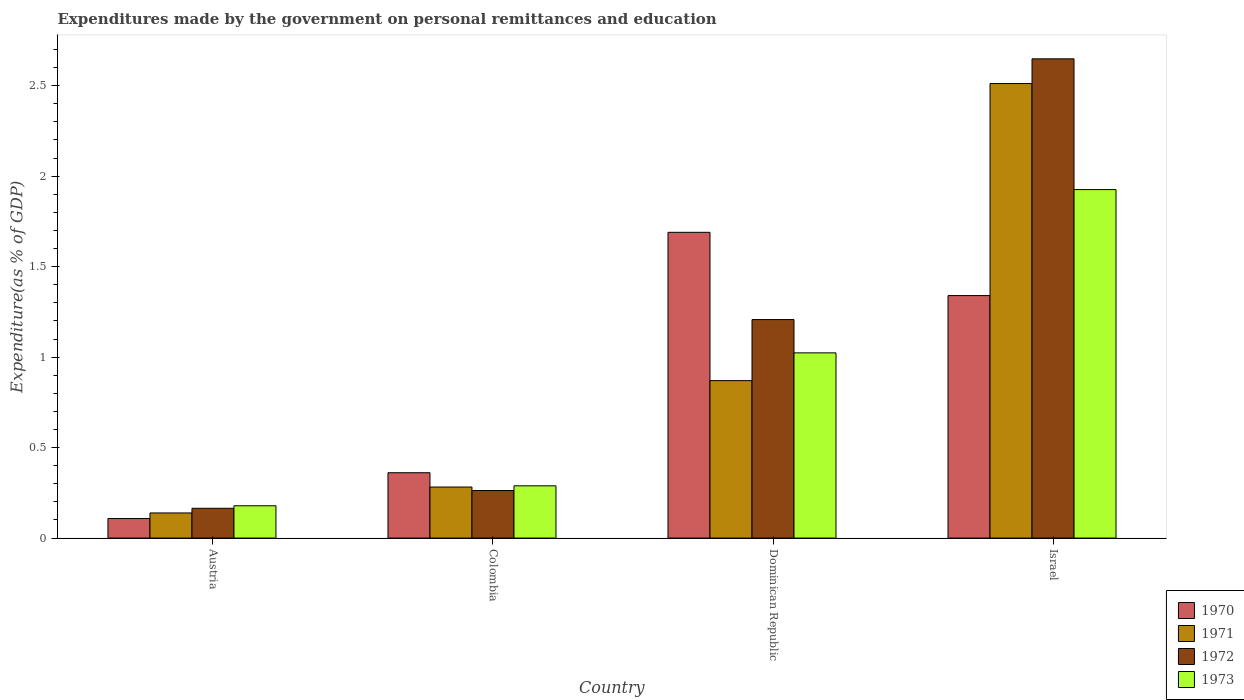How many different coloured bars are there?
Ensure brevity in your answer.  4. How many groups of bars are there?
Your answer should be compact. 4. Are the number of bars per tick equal to the number of legend labels?
Provide a short and direct response. Yes. How many bars are there on the 4th tick from the right?
Keep it short and to the point. 4. In how many cases, is the number of bars for a given country not equal to the number of legend labels?
Keep it short and to the point. 0. What is the expenditures made by the government on personal remittances and education in 1973 in Colombia?
Your response must be concise. 0.29. Across all countries, what is the maximum expenditures made by the government on personal remittances and education in 1971?
Make the answer very short. 2.51. Across all countries, what is the minimum expenditures made by the government on personal remittances and education in 1973?
Provide a short and direct response. 0.18. In which country was the expenditures made by the government on personal remittances and education in 1970 maximum?
Your response must be concise. Dominican Republic. In which country was the expenditures made by the government on personal remittances and education in 1972 minimum?
Ensure brevity in your answer.  Austria. What is the total expenditures made by the government on personal remittances and education in 1972 in the graph?
Offer a terse response. 4.28. What is the difference between the expenditures made by the government on personal remittances and education in 1973 in Austria and that in Dominican Republic?
Provide a succinct answer. -0.84. What is the difference between the expenditures made by the government on personal remittances and education in 1972 in Israel and the expenditures made by the government on personal remittances and education in 1973 in Austria?
Offer a terse response. 2.47. What is the average expenditures made by the government on personal remittances and education in 1972 per country?
Ensure brevity in your answer.  1.07. What is the difference between the expenditures made by the government on personal remittances and education of/in 1972 and expenditures made by the government on personal remittances and education of/in 1973 in Austria?
Ensure brevity in your answer.  -0.01. In how many countries, is the expenditures made by the government on personal remittances and education in 1970 greater than 2.6 %?
Your response must be concise. 0. What is the ratio of the expenditures made by the government on personal remittances and education in 1971 in Dominican Republic to that in Israel?
Ensure brevity in your answer.  0.35. Is the difference between the expenditures made by the government on personal remittances and education in 1972 in Austria and Colombia greater than the difference between the expenditures made by the government on personal remittances and education in 1973 in Austria and Colombia?
Keep it short and to the point. Yes. What is the difference between the highest and the second highest expenditures made by the government on personal remittances and education in 1970?
Keep it short and to the point. -1.33. What is the difference between the highest and the lowest expenditures made by the government on personal remittances and education in 1971?
Your answer should be compact. 2.37. Is the sum of the expenditures made by the government on personal remittances and education in 1970 in Colombia and Dominican Republic greater than the maximum expenditures made by the government on personal remittances and education in 1973 across all countries?
Make the answer very short. Yes. Is it the case that in every country, the sum of the expenditures made by the government on personal remittances and education in 1971 and expenditures made by the government on personal remittances and education in 1973 is greater than the sum of expenditures made by the government on personal remittances and education in 1970 and expenditures made by the government on personal remittances and education in 1972?
Offer a very short reply. No. What does the 3rd bar from the left in Austria represents?
Your response must be concise. 1972. How many bars are there?
Offer a very short reply. 16. Are all the bars in the graph horizontal?
Provide a succinct answer. No. Does the graph contain any zero values?
Make the answer very short. No. Does the graph contain grids?
Offer a terse response. No. What is the title of the graph?
Provide a short and direct response. Expenditures made by the government on personal remittances and education. Does "2015" appear as one of the legend labels in the graph?
Your answer should be very brief. No. What is the label or title of the Y-axis?
Your answer should be very brief. Expenditure(as % of GDP). What is the Expenditure(as % of GDP) of 1970 in Austria?
Ensure brevity in your answer.  0.11. What is the Expenditure(as % of GDP) in 1971 in Austria?
Ensure brevity in your answer.  0.14. What is the Expenditure(as % of GDP) of 1972 in Austria?
Provide a short and direct response. 0.16. What is the Expenditure(as % of GDP) in 1973 in Austria?
Your response must be concise. 0.18. What is the Expenditure(as % of GDP) of 1970 in Colombia?
Give a very brief answer. 0.36. What is the Expenditure(as % of GDP) in 1971 in Colombia?
Keep it short and to the point. 0.28. What is the Expenditure(as % of GDP) of 1972 in Colombia?
Provide a succinct answer. 0.26. What is the Expenditure(as % of GDP) of 1973 in Colombia?
Offer a very short reply. 0.29. What is the Expenditure(as % of GDP) in 1970 in Dominican Republic?
Your answer should be very brief. 1.69. What is the Expenditure(as % of GDP) of 1971 in Dominican Republic?
Give a very brief answer. 0.87. What is the Expenditure(as % of GDP) of 1972 in Dominican Republic?
Give a very brief answer. 1.21. What is the Expenditure(as % of GDP) in 1973 in Dominican Republic?
Give a very brief answer. 1.02. What is the Expenditure(as % of GDP) of 1970 in Israel?
Keep it short and to the point. 1.34. What is the Expenditure(as % of GDP) in 1971 in Israel?
Offer a very short reply. 2.51. What is the Expenditure(as % of GDP) of 1972 in Israel?
Your answer should be compact. 2.65. What is the Expenditure(as % of GDP) of 1973 in Israel?
Provide a short and direct response. 1.93. Across all countries, what is the maximum Expenditure(as % of GDP) of 1970?
Ensure brevity in your answer.  1.69. Across all countries, what is the maximum Expenditure(as % of GDP) in 1971?
Ensure brevity in your answer.  2.51. Across all countries, what is the maximum Expenditure(as % of GDP) in 1972?
Provide a short and direct response. 2.65. Across all countries, what is the maximum Expenditure(as % of GDP) in 1973?
Your response must be concise. 1.93. Across all countries, what is the minimum Expenditure(as % of GDP) in 1970?
Provide a short and direct response. 0.11. Across all countries, what is the minimum Expenditure(as % of GDP) of 1971?
Give a very brief answer. 0.14. Across all countries, what is the minimum Expenditure(as % of GDP) in 1972?
Ensure brevity in your answer.  0.16. Across all countries, what is the minimum Expenditure(as % of GDP) of 1973?
Provide a succinct answer. 0.18. What is the total Expenditure(as % of GDP) in 1970 in the graph?
Your answer should be compact. 3.5. What is the total Expenditure(as % of GDP) of 1971 in the graph?
Ensure brevity in your answer.  3.8. What is the total Expenditure(as % of GDP) of 1972 in the graph?
Keep it short and to the point. 4.28. What is the total Expenditure(as % of GDP) of 1973 in the graph?
Make the answer very short. 3.42. What is the difference between the Expenditure(as % of GDP) in 1970 in Austria and that in Colombia?
Make the answer very short. -0.25. What is the difference between the Expenditure(as % of GDP) of 1971 in Austria and that in Colombia?
Your answer should be compact. -0.14. What is the difference between the Expenditure(as % of GDP) in 1972 in Austria and that in Colombia?
Your answer should be very brief. -0.1. What is the difference between the Expenditure(as % of GDP) of 1973 in Austria and that in Colombia?
Ensure brevity in your answer.  -0.11. What is the difference between the Expenditure(as % of GDP) in 1970 in Austria and that in Dominican Republic?
Your answer should be compact. -1.58. What is the difference between the Expenditure(as % of GDP) in 1971 in Austria and that in Dominican Republic?
Give a very brief answer. -0.73. What is the difference between the Expenditure(as % of GDP) of 1972 in Austria and that in Dominican Republic?
Ensure brevity in your answer.  -1.04. What is the difference between the Expenditure(as % of GDP) of 1973 in Austria and that in Dominican Republic?
Make the answer very short. -0.84. What is the difference between the Expenditure(as % of GDP) in 1970 in Austria and that in Israel?
Provide a short and direct response. -1.23. What is the difference between the Expenditure(as % of GDP) of 1971 in Austria and that in Israel?
Ensure brevity in your answer.  -2.37. What is the difference between the Expenditure(as % of GDP) of 1972 in Austria and that in Israel?
Offer a very short reply. -2.48. What is the difference between the Expenditure(as % of GDP) in 1973 in Austria and that in Israel?
Keep it short and to the point. -1.75. What is the difference between the Expenditure(as % of GDP) of 1970 in Colombia and that in Dominican Republic?
Your answer should be very brief. -1.33. What is the difference between the Expenditure(as % of GDP) of 1971 in Colombia and that in Dominican Republic?
Make the answer very short. -0.59. What is the difference between the Expenditure(as % of GDP) of 1972 in Colombia and that in Dominican Republic?
Provide a short and direct response. -0.94. What is the difference between the Expenditure(as % of GDP) of 1973 in Colombia and that in Dominican Republic?
Your answer should be very brief. -0.73. What is the difference between the Expenditure(as % of GDP) in 1970 in Colombia and that in Israel?
Provide a succinct answer. -0.98. What is the difference between the Expenditure(as % of GDP) of 1971 in Colombia and that in Israel?
Your answer should be very brief. -2.23. What is the difference between the Expenditure(as % of GDP) of 1972 in Colombia and that in Israel?
Give a very brief answer. -2.39. What is the difference between the Expenditure(as % of GDP) in 1973 in Colombia and that in Israel?
Give a very brief answer. -1.64. What is the difference between the Expenditure(as % of GDP) of 1970 in Dominican Republic and that in Israel?
Ensure brevity in your answer.  0.35. What is the difference between the Expenditure(as % of GDP) in 1971 in Dominican Republic and that in Israel?
Give a very brief answer. -1.64. What is the difference between the Expenditure(as % of GDP) in 1972 in Dominican Republic and that in Israel?
Your answer should be very brief. -1.44. What is the difference between the Expenditure(as % of GDP) of 1973 in Dominican Republic and that in Israel?
Provide a succinct answer. -0.9. What is the difference between the Expenditure(as % of GDP) of 1970 in Austria and the Expenditure(as % of GDP) of 1971 in Colombia?
Make the answer very short. -0.17. What is the difference between the Expenditure(as % of GDP) of 1970 in Austria and the Expenditure(as % of GDP) of 1972 in Colombia?
Ensure brevity in your answer.  -0.15. What is the difference between the Expenditure(as % of GDP) in 1970 in Austria and the Expenditure(as % of GDP) in 1973 in Colombia?
Make the answer very short. -0.18. What is the difference between the Expenditure(as % of GDP) in 1971 in Austria and the Expenditure(as % of GDP) in 1972 in Colombia?
Make the answer very short. -0.12. What is the difference between the Expenditure(as % of GDP) in 1971 in Austria and the Expenditure(as % of GDP) in 1973 in Colombia?
Give a very brief answer. -0.15. What is the difference between the Expenditure(as % of GDP) in 1972 in Austria and the Expenditure(as % of GDP) in 1973 in Colombia?
Offer a terse response. -0.12. What is the difference between the Expenditure(as % of GDP) of 1970 in Austria and the Expenditure(as % of GDP) of 1971 in Dominican Republic?
Make the answer very short. -0.76. What is the difference between the Expenditure(as % of GDP) of 1970 in Austria and the Expenditure(as % of GDP) of 1972 in Dominican Republic?
Your answer should be compact. -1.1. What is the difference between the Expenditure(as % of GDP) of 1970 in Austria and the Expenditure(as % of GDP) of 1973 in Dominican Republic?
Give a very brief answer. -0.92. What is the difference between the Expenditure(as % of GDP) of 1971 in Austria and the Expenditure(as % of GDP) of 1972 in Dominican Republic?
Ensure brevity in your answer.  -1.07. What is the difference between the Expenditure(as % of GDP) of 1971 in Austria and the Expenditure(as % of GDP) of 1973 in Dominican Republic?
Offer a very short reply. -0.88. What is the difference between the Expenditure(as % of GDP) in 1972 in Austria and the Expenditure(as % of GDP) in 1973 in Dominican Republic?
Keep it short and to the point. -0.86. What is the difference between the Expenditure(as % of GDP) in 1970 in Austria and the Expenditure(as % of GDP) in 1971 in Israel?
Give a very brief answer. -2.4. What is the difference between the Expenditure(as % of GDP) of 1970 in Austria and the Expenditure(as % of GDP) of 1972 in Israel?
Keep it short and to the point. -2.54. What is the difference between the Expenditure(as % of GDP) of 1970 in Austria and the Expenditure(as % of GDP) of 1973 in Israel?
Provide a short and direct response. -1.82. What is the difference between the Expenditure(as % of GDP) of 1971 in Austria and the Expenditure(as % of GDP) of 1972 in Israel?
Keep it short and to the point. -2.51. What is the difference between the Expenditure(as % of GDP) of 1971 in Austria and the Expenditure(as % of GDP) of 1973 in Israel?
Your answer should be compact. -1.79. What is the difference between the Expenditure(as % of GDP) of 1972 in Austria and the Expenditure(as % of GDP) of 1973 in Israel?
Make the answer very short. -1.76. What is the difference between the Expenditure(as % of GDP) of 1970 in Colombia and the Expenditure(as % of GDP) of 1971 in Dominican Republic?
Offer a very short reply. -0.51. What is the difference between the Expenditure(as % of GDP) of 1970 in Colombia and the Expenditure(as % of GDP) of 1972 in Dominican Republic?
Provide a short and direct response. -0.85. What is the difference between the Expenditure(as % of GDP) of 1970 in Colombia and the Expenditure(as % of GDP) of 1973 in Dominican Republic?
Your response must be concise. -0.66. What is the difference between the Expenditure(as % of GDP) of 1971 in Colombia and the Expenditure(as % of GDP) of 1972 in Dominican Republic?
Ensure brevity in your answer.  -0.93. What is the difference between the Expenditure(as % of GDP) in 1971 in Colombia and the Expenditure(as % of GDP) in 1973 in Dominican Republic?
Your answer should be compact. -0.74. What is the difference between the Expenditure(as % of GDP) of 1972 in Colombia and the Expenditure(as % of GDP) of 1973 in Dominican Republic?
Give a very brief answer. -0.76. What is the difference between the Expenditure(as % of GDP) of 1970 in Colombia and the Expenditure(as % of GDP) of 1971 in Israel?
Give a very brief answer. -2.15. What is the difference between the Expenditure(as % of GDP) of 1970 in Colombia and the Expenditure(as % of GDP) of 1972 in Israel?
Ensure brevity in your answer.  -2.29. What is the difference between the Expenditure(as % of GDP) of 1970 in Colombia and the Expenditure(as % of GDP) of 1973 in Israel?
Your answer should be very brief. -1.56. What is the difference between the Expenditure(as % of GDP) in 1971 in Colombia and the Expenditure(as % of GDP) in 1972 in Israel?
Provide a short and direct response. -2.37. What is the difference between the Expenditure(as % of GDP) of 1971 in Colombia and the Expenditure(as % of GDP) of 1973 in Israel?
Make the answer very short. -1.64. What is the difference between the Expenditure(as % of GDP) in 1972 in Colombia and the Expenditure(as % of GDP) in 1973 in Israel?
Give a very brief answer. -1.66. What is the difference between the Expenditure(as % of GDP) in 1970 in Dominican Republic and the Expenditure(as % of GDP) in 1971 in Israel?
Your answer should be very brief. -0.82. What is the difference between the Expenditure(as % of GDP) in 1970 in Dominican Republic and the Expenditure(as % of GDP) in 1972 in Israel?
Offer a terse response. -0.96. What is the difference between the Expenditure(as % of GDP) of 1970 in Dominican Republic and the Expenditure(as % of GDP) of 1973 in Israel?
Your response must be concise. -0.24. What is the difference between the Expenditure(as % of GDP) of 1971 in Dominican Republic and the Expenditure(as % of GDP) of 1972 in Israel?
Your answer should be compact. -1.78. What is the difference between the Expenditure(as % of GDP) in 1971 in Dominican Republic and the Expenditure(as % of GDP) in 1973 in Israel?
Offer a very short reply. -1.06. What is the difference between the Expenditure(as % of GDP) of 1972 in Dominican Republic and the Expenditure(as % of GDP) of 1973 in Israel?
Give a very brief answer. -0.72. What is the average Expenditure(as % of GDP) of 1970 per country?
Keep it short and to the point. 0.87. What is the average Expenditure(as % of GDP) in 1971 per country?
Your answer should be very brief. 0.95. What is the average Expenditure(as % of GDP) of 1972 per country?
Give a very brief answer. 1.07. What is the average Expenditure(as % of GDP) in 1973 per country?
Give a very brief answer. 0.85. What is the difference between the Expenditure(as % of GDP) of 1970 and Expenditure(as % of GDP) of 1971 in Austria?
Keep it short and to the point. -0.03. What is the difference between the Expenditure(as % of GDP) of 1970 and Expenditure(as % of GDP) of 1972 in Austria?
Give a very brief answer. -0.06. What is the difference between the Expenditure(as % of GDP) of 1970 and Expenditure(as % of GDP) of 1973 in Austria?
Offer a very short reply. -0.07. What is the difference between the Expenditure(as % of GDP) of 1971 and Expenditure(as % of GDP) of 1972 in Austria?
Provide a short and direct response. -0.03. What is the difference between the Expenditure(as % of GDP) of 1971 and Expenditure(as % of GDP) of 1973 in Austria?
Offer a terse response. -0.04. What is the difference between the Expenditure(as % of GDP) of 1972 and Expenditure(as % of GDP) of 1973 in Austria?
Your response must be concise. -0.01. What is the difference between the Expenditure(as % of GDP) in 1970 and Expenditure(as % of GDP) in 1971 in Colombia?
Offer a very short reply. 0.08. What is the difference between the Expenditure(as % of GDP) of 1970 and Expenditure(as % of GDP) of 1972 in Colombia?
Provide a short and direct response. 0.1. What is the difference between the Expenditure(as % of GDP) of 1970 and Expenditure(as % of GDP) of 1973 in Colombia?
Keep it short and to the point. 0.07. What is the difference between the Expenditure(as % of GDP) of 1971 and Expenditure(as % of GDP) of 1972 in Colombia?
Provide a succinct answer. 0.02. What is the difference between the Expenditure(as % of GDP) of 1971 and Expenditure(as % of GDP) of 1973 in Colombia?
Keep it short and to the point. -0.01. What is the difference between the Expenditure(as % of GDP) in 1972 and Expenditure(as % of GDP) in 1973 in Colombia?
Offer a terse response. -0.03. What is the difference between the Expenditure(as % of GDP) in 1970 and Expenditure(as % of GDP) in 1971 in Dominican Republic?
Ensure brevity in your answer.  0.82. What is the difference between the Expenditure(as % of GDP) of 1970 and Expenditure(as % of GDP) of 1972 in Dominican Republic?
Keep it short and to the point. 0.48. What is the difference between the Expenditure(as % of GDP) in 1970 and Expenditure(as % of GDP) in 1973 in Dominican Republic?
Offer a terse response. 0.67. What is the difference between the Expenditure(as % of GDP) of 1971 and Expenditure(as % of GDP) of 1972 in Dominican Republic?
Offer a very short reply. -0.34. What is the difference between the Expenditure(as % of GDP) of 1971 and Expenditure(as % of GDP) of 1973 in Dominican Republic?
Keep it short and to the point. -0.15. What is the difference between the Expenditure(as % of GDP) of 1972 and Expenditure(as % of GDP) of 1973 in Dominican Republic?
Your response must be concise. 0.18. What is the difference between the Expenditure(as % of GDP) of 1970 and Expenditure(as % of GDP) of 1971 in Israel?
Provide a succinct answer. -1.17. What is the difference between the Expenditure(as % of GDP) of 1970 and Expenditure(as % of GDP) of 1972 in Israel?
Your answer should be compact. -1.31. What is the difference between the Expenditure(as % of GDP) in 1970 and Expenditure(as % of GDP) in 1973 in Israel?
Your response must be concise. -0.59. What is the difference between the Expenditure(as % of GDP) in 1971 and Expenditure(as % of GDP) in 1972 in Israel?
Provide a short and direct response. -0.14. What is the difference between the Expenditure(as % of GDP) of 1971 and Expenditure(as % of GDP) of 1973 in Israel?
Your answer should be compact. 0.59. What is the difference between the Expenditure(as % of GDP) in 1972 and Expenditure(as % of GDP) in 1973 in Israel?
Your answer should be compact. 0.72. What is the ratio of the Expenditure(as % of GDP) in 1970 in Austria to that in Colombia?
Offer a terse response. 0.3. What is the ratio of the Expenditure(as % of GDP) in 1971 in Austria to that in Colombia?
Your response must be concise. 0.49. What is the ratio of the Expenditure(as % of GDP) in 1972 in Austria to that in Colombia?
Provide a succinct answer. 0.63. What is the ratio of the Expenditure(as % of GDP) in 1973 in Austria to that in Colombia?
Give a very brief answer. 0.62. What is the ratio of the Expenditure(as % of GDP) of 1970 in Austria to that in Dominican Republic?
Provide a short and direct response. 0.06. What is the ratio of the Expenditure(as % of GDP) of 1971 in Austria to that in Dominican Republic?
Provide a short and direct response. 0.16. What is the ratio of the Expenditure(as % of GDP) of 1972 in Austria to that in Dominican Republic?
Keep it short and to the point. 0.14. What is the ratio of the Expenditure(as % of GDP) of 1973 in Austria to that in Dominican Republic?
Your answer should be compact. 0.17. What is the ratio of the Expenditure(as % of GDP) in 1970 in Austria to that in Israel?
Offer a terse response. 0.08. What is the ratio of the Expenditure(as % of GDP) in 1971 in Austria to that in Israel?
Offer a terse response. 0.06. What is the ratio of the Expenditure(as % of GDP) of 1972 in Austria to that in Israel?
Provide a succinct answer. 0.06. What is the ratio of the Expenditure(as % of GDP) of 1973 in Austria to that in Israel?
Keep it short and to the point. 0.09. What is the ratio of the Expenditure(as % of GDP) of 1970 in Colombia to that in Dominican Republic?
Your answer should be very brief. 0.21. What is the ratio of the Expenditure(as % of GDP) in 1971 in Colombia to that in Dominican Republic?
Your answer should be compact. 0.32. What is the ratio of the Expenditure(as % of GDP) in 1972 in Colombia to that in Dominican Republic?
Offer a terse response. 0.22. What is the ratio of the Expenditure(as % of GDP) of 1973 in Colombia to that in Dominican Republic?
Your answer should be very brief. 0.28. What is the ratio of the Expenditure(as % of GDP) in 1970 in Colombia to that in Israel?
Provide a short and direct response. 0.27. What is the ratio of the Expenditure(as % of GDP) of 1971 in Colombia to that in Israel?
Offer a terse response. 0.11. What is the ratio of the Expenditure(as % of GDP) in 1972 in Colombia to that in Israel?
Offer a very short reply. 0.1. What is the ratio of the Expenditure(as % of GDP) in 1973 in Colombia to that in Israel?
Make the answer very short. 0.15. What is the ratio of the Expenditure(as % of GDP) of 1970 in Dominican Republic to that in Israel?
Offer a very short reply. 1.26. What is the ratio of the Expenditure(as % of GDP) of 1971 in Dominican Republic to that in Israel?
Your response must be concise. 0.35. What is the ratio of the Expenditure(as % of GDP) of 1972 in Dominican Republic to that in Israel?
Give a very brief answer. 0.46. What is the ratio of the Expenditure(as % of GDP) of 1973 in Dominican Republic to that in Israel?
Keep it short and to the point. 0.53. What is the difference between the highest and the second highest Expenditure(as % of GDP) in 1970?
Offer a very short reply. 0.35. What is the difference between the highest and the second highest Expenditure(as % of GDP) of 1971?
Keep it short and to the point. 1.64. What is the difference between the highest and the second highest Expenditure(as % of GDP) in 1972?
Ensure brevity in your answer.  1.44. What is the difference between the highest and the second highest Expenditure(as % of GDP) in 1973?
Provide a succinct answer. 0.9. What is the difference between the highest and the lowest Expenditure(as % of GDP) of 1970?
Keep it short and to the point. 1.58. What is the difference between the highest and the lowest Expenditure(as % of GDP) of 1971?
Your answer should be compact. 2.37. What is the difference between the highest and the lowest Expenditure(as % of GDP) of 1972?
Keep it short and to the point. 2.48. What is the difference between the highest and the lowest Expenditure(as % of GDP) in 1973?
Keep it short and to the point. 1.75. 